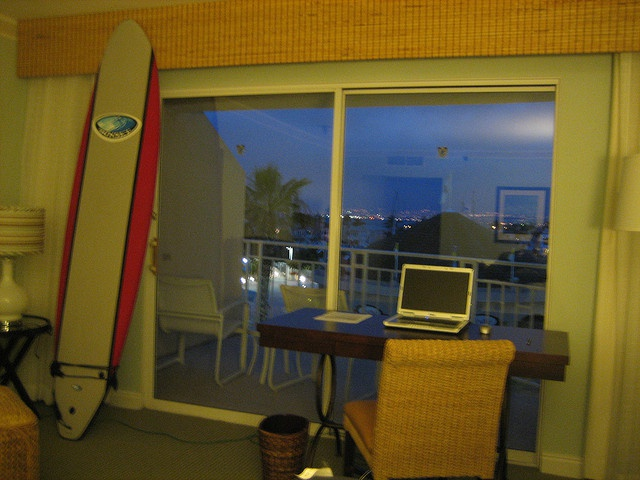Describe the objects in this image and their specific colors. I can see surfboard in olive, maroon, and black tones, chair in olive, maroon, and black tones, chair in olive, darkgreen, black, and gray tones, laptop in olive, black, and khaki tones, and chair in olive, gray, navy, and darkgray tones in this image. 